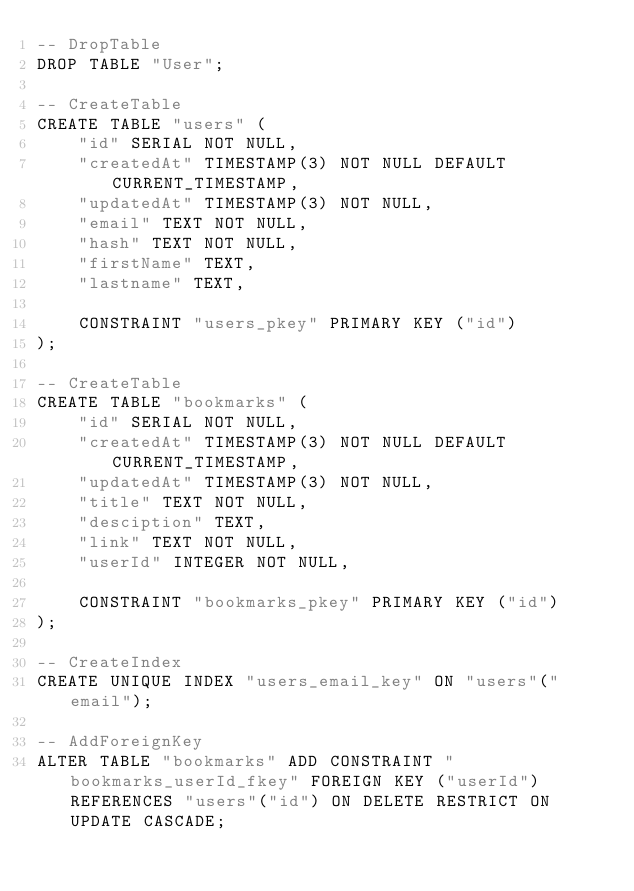Convert code to text. <code><loc_0><loc_0><loc_500><loc_500><_SQL_>-- DropTable
DROP TABLE "User";

-- CreateTable
CREATE TABLE "users" (
    "id" SERIAL NOT NULL,
    "createdAt" TIMESTAMP(3) NOT NULL DEFAULT CURRENT_TIMESTAMP,
    "updatedAt" TIMESTAMP(3) NOT NULL,
    "email" TEXT NOT NULL,
    "hash" TEXT NOT NULL,
    "firstName" TEXT,
    "lastname" TEXT,

    CONSTRAINT "users_pkey" PRIMARY KEY ("id")
);

-- CreateTable
CREATE TABLE "bookmarks" (
    "id" SERIAL NOT NULL,
    "createdAt" TIMESTAMP(3) NOT NULL DEFAULT CURRENT_TIMESTAMP,
    "updatedAt" TIMESTAMP(3) NOT NULL,
    "title" TEXT NOT NULL,
    "desciption" TEXT,
    "link" TEXT NOT NULL,
    "userId" INTEGER NOT NULL,

    CONSTRAINT "bookmarks_pkey" PRIMARY KEY ("id")
);

-- CreateIndex
CREATE UNIQUE INDEX "users_email_key" ON "users"("email");

-- AddForeignKey
ALTER TABLE "bookmarks" ADD CONSTRAINT "bookmarks_userId_fkey" FOREIGN KEY ("userId") REFERENCES "users"("id") ON DELETE RESTRICT ON UPDATE CASCADE;
</code> 